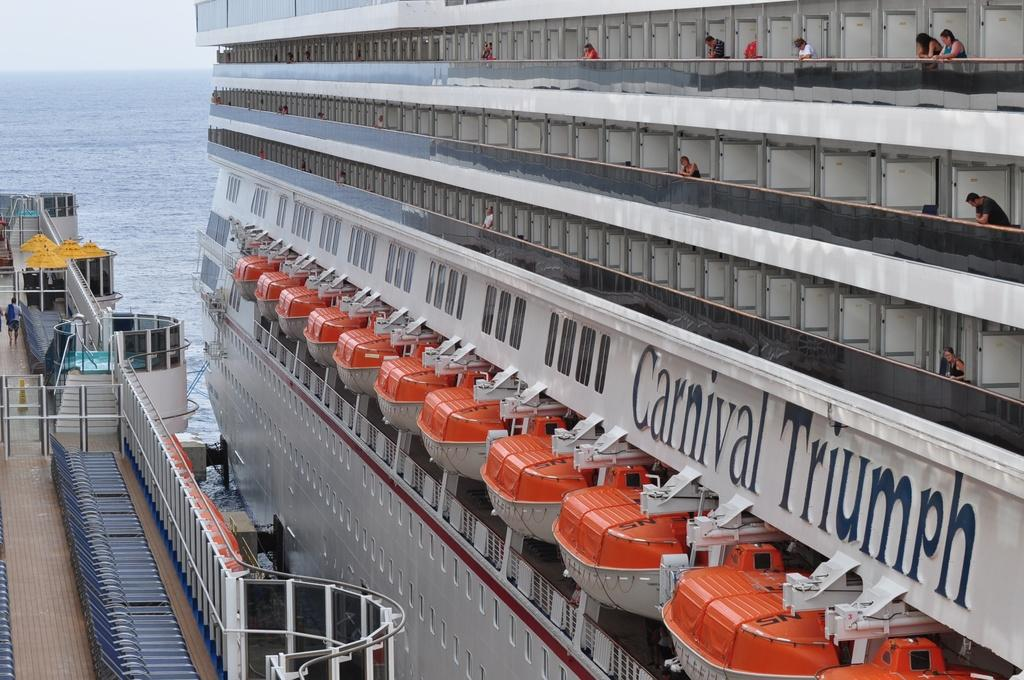What can be seen in the image? There are two ships in the image. What are the people doing on the ships? The people are standing in various compartments of the ships. What is the surrounding environment in the image? There is a sea visible in the image. How does the ship apply its brake while in the water? Ships do not have brakes like vehicles; they slow down or stop by adjusting their speed and direction. 